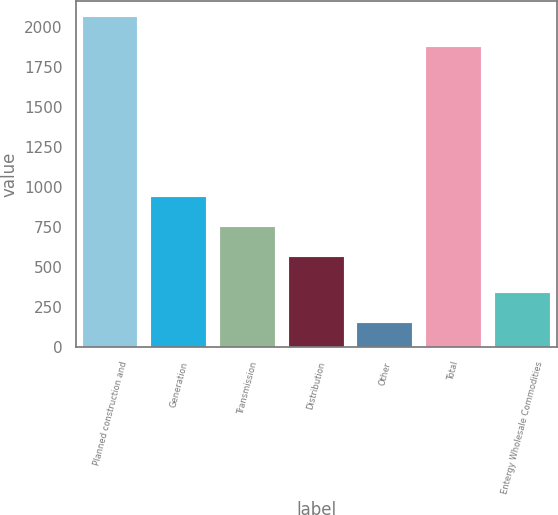Convert chart. <chart><loc_0><loc_0><loc_500><loc_500><bar_chart><fcel>Planned construction and<fcel>Generation<fcel>Transmission<fcel>Distribution<fcel>Other<fcel>Total<fcel>Entergy Wholesale Commodities<nl><fcel>2061.6<fcel>938.2<fcel>751.6<fcel>565<fcel>150<fcel>1875<fcel>336.6<nl></chart> 